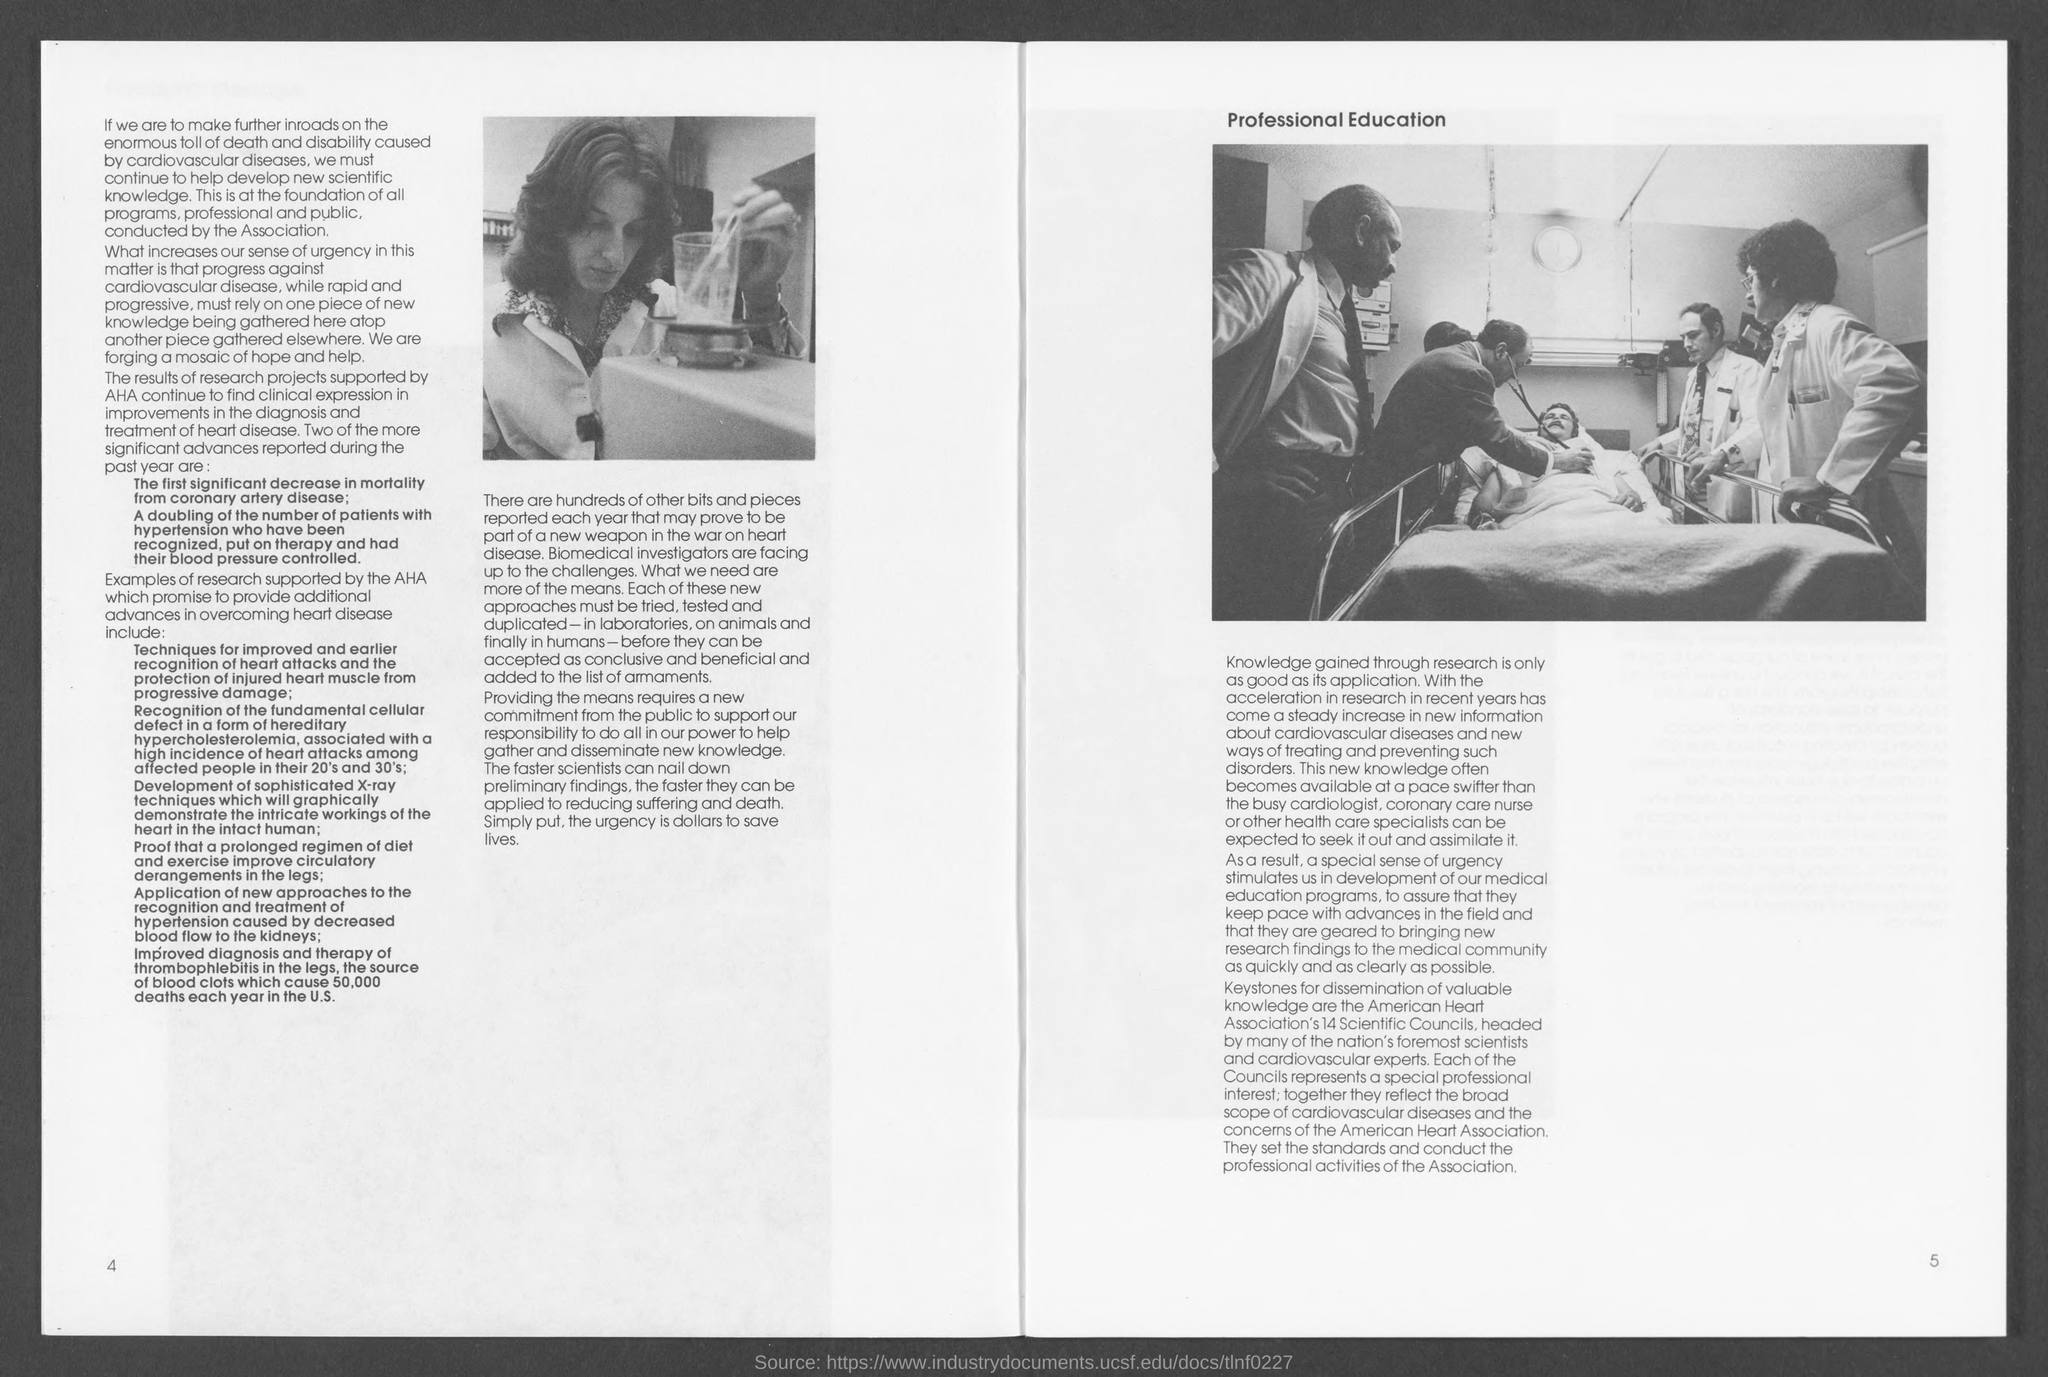Highlight a few significant elements in this photo. Cardiovascular disease is a condition that affects the heart and blood vessels. 